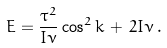Convert formula to latex. <formula><loc_0><loc_0><loc_500><loc_500>E = \frac { \tau ^ { 2 } } { I \nu } \cos ^ { 2 } k \, + \, 2 I \nu \, .</formula> 